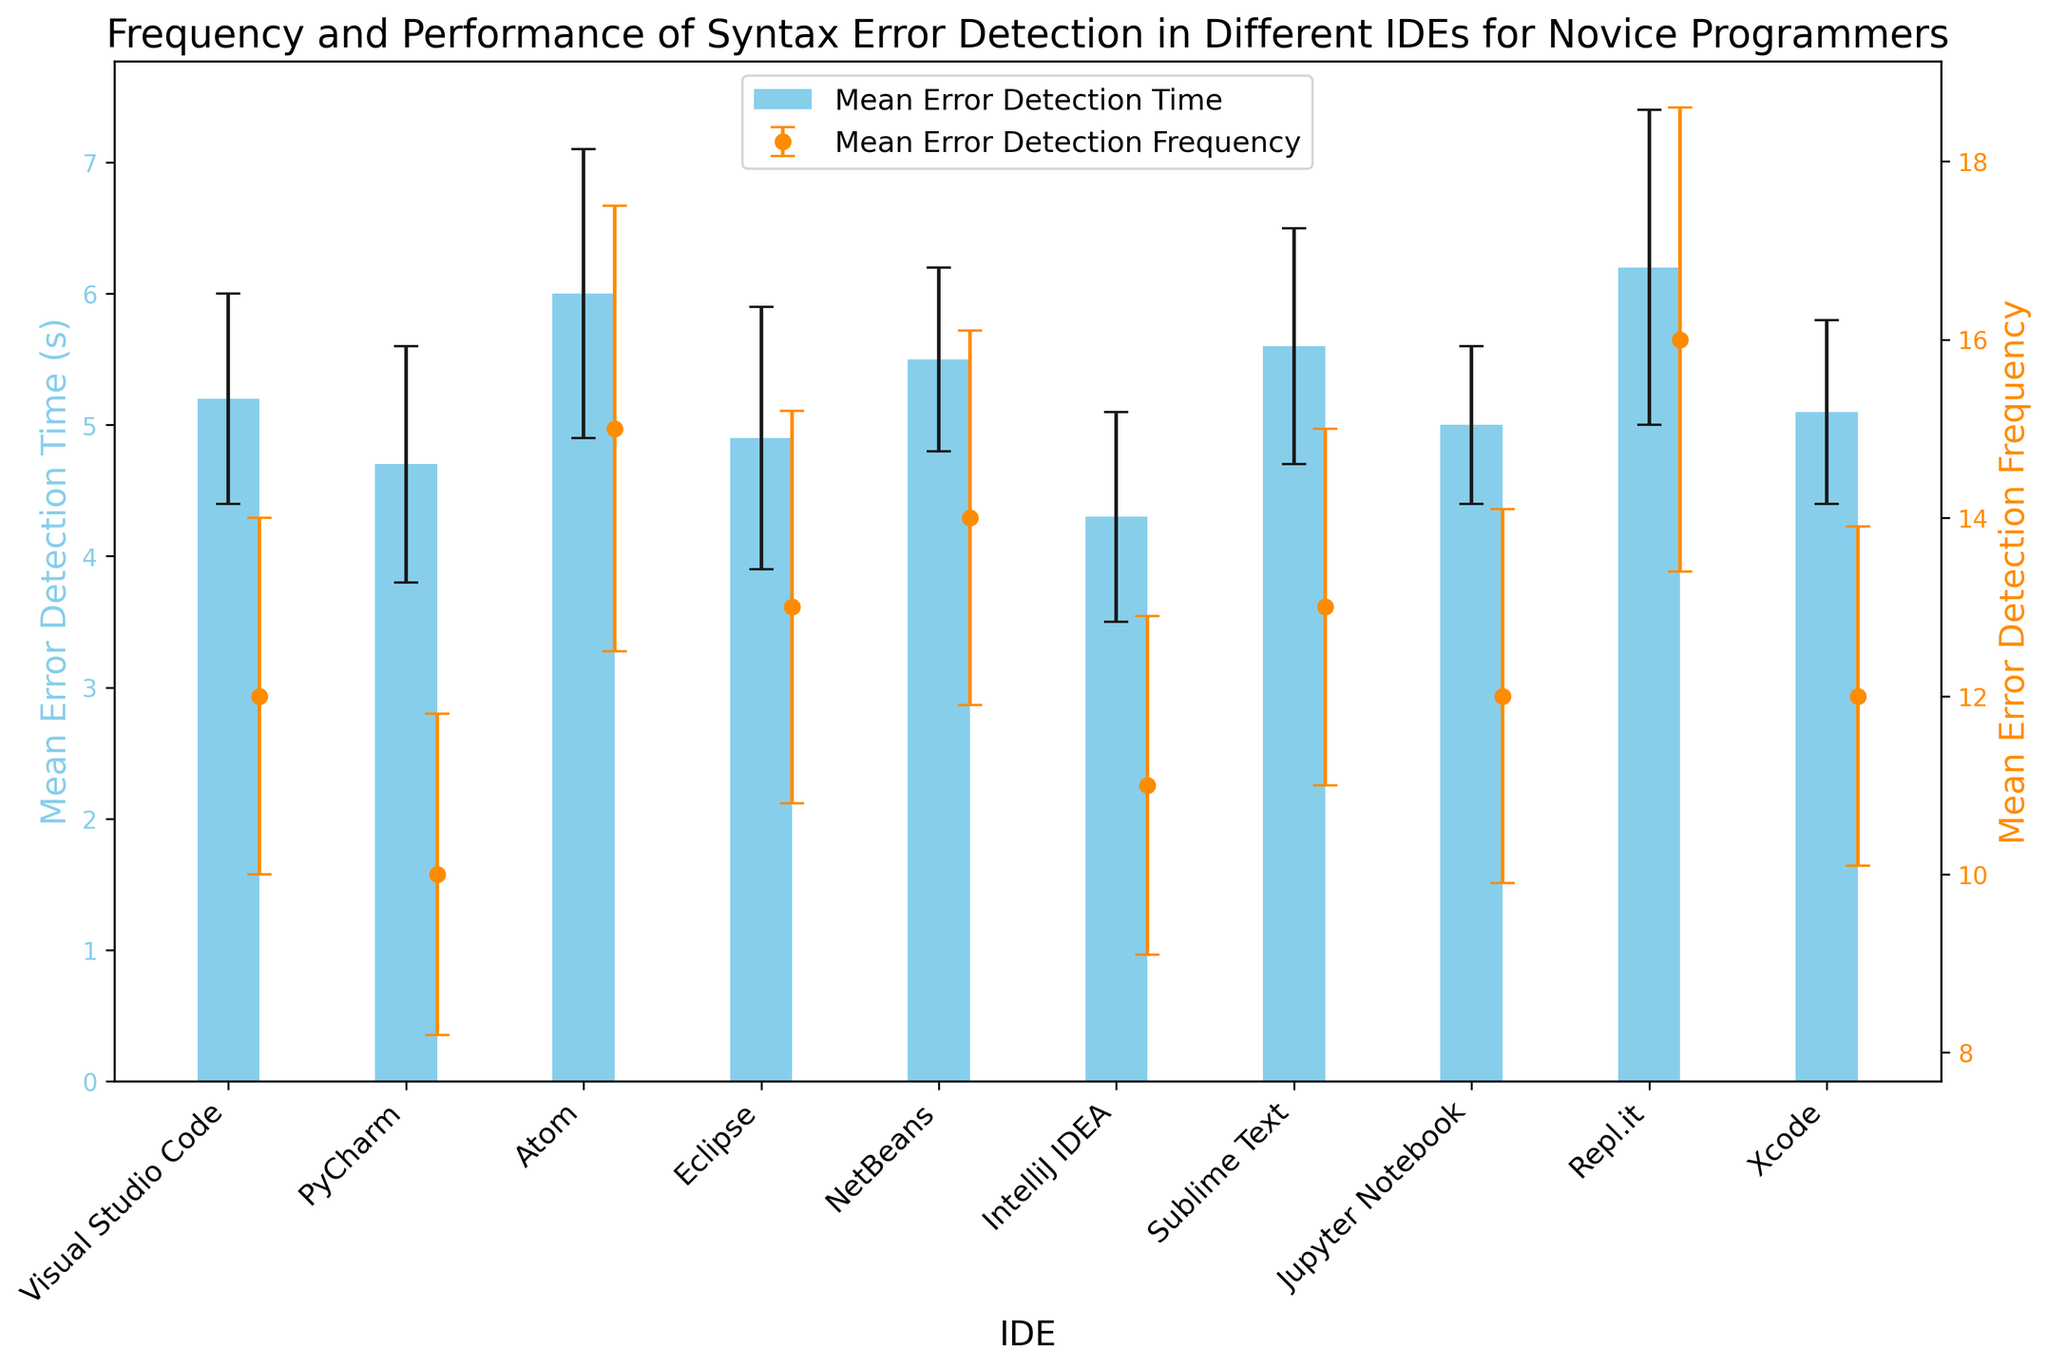Which IDE has the lowest mean error detection time? By observing the heights of the bars representing the mean error detection times, the shortest bar indicates the lowest mean time. IntelliJ IDEA has the lowest bar for this metric.
Answer: IntelliJ IDEA Which IDE has the highest mean error detection frequency? The highest point in the scatter plot representing the mean error detection frequency indicates the IDE with the highest frequency. Repl.it has the highest point.
Answer: Repl.it What is the difference in mean error detection time between Visual Studio Code and Eclipse? Visual Studio Code has a mean time of 5.2 seconds, and Eclipse has a mean time of 4.9 seconds. Subtract the Eclipse time from the Visual Studio Code time: 5.2 - 4.9.
Answer: 0.3 seconds Which IDEs have a mean error detection frequency of 12? Identifying the points on the scatter plot that line up with the value 12 on the y-axis for mean error detection frequency, we find the corresponding IDEs. These are Visual Studio Code, Jupyter Notebook, and Xcode.
Answer: Visual Studio Code, Jupyter Notebook, Xcode How much greater is the mean error detection frequency in Repl.it compared to Atom? Repl.it has a frequency of 16, and Atom has a frequency of 15. Subtract the Atom frequency from the Repl.it frequency: 16 - 15.
Answer: 1 Which IDEs have mean error detection times between 5 and 6 seconds? Checking the bars for mean error detection times that fall between 5 and 6 seconds, we find Visual Studio Code, NetBeans, Sublime Text, and Xcode.
Answer: Visual Studio Code, NetBeans, Sublime Text, Xcode By how much does PyCharm’s mean error detection time differ from the mean value of all IDEs' mean error detection times? First, calculate the mean of all mean error detection times:
(5.2 + 4.7 + 6.0 + 4.9 + 5.5 + 4.3 + 5.6 + 5.0 + 6.2 + 5.1) / 10 = 5.25. 
Now, find the difference between PyCharm's mean time (4.7) and the calculated mean: 5.25 - 4.7.
Answer: 0.55 seconds Which IDE’s mean error detection time has the largest standard deviation? By comparing the error bars representing the standard deviations, we see the largest error bar is associated with Repl.it.
Answer: Repl.it What are the mean error detection times for the IDEs with a mean error detection frequency of 13? Check the scatter plot for the frequency points that align with 13, identifying Eclipse and Sublime Text. Their mean error detection times from the bar plot are 4.9 and 5.6 seconds respectively.
Answer: Eclipse: 4.9, Sublime Text: 5.6 seconds Which IDE's error detection time standard deviation is closest to 1? By examining the lengths of the error bars, Eclipse and Atom both have standard deviations of 1 or close to 1.
Answer: Eclipse, Atom 